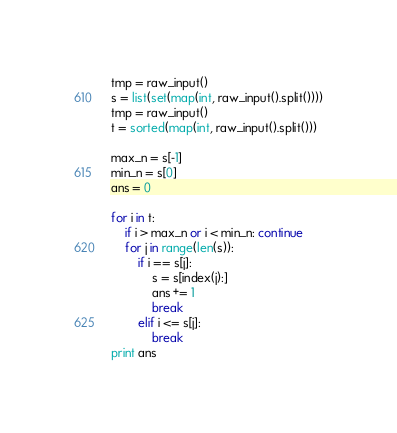Convert code to text. <code><loc_0><loc_0><loc_500><loc_500><_Python_>tmp = raw_input()
s = list(set(map(int, raw_input().split())))
tmp = raw_input()
t = sorted(map(int, raw_input().split()))

max_n = s[-1]
min_n = s[0]
ans = 0

for i in t:
	if i > max_n or i < min_n: continue
	for j in range(len(s)):
		if i == s[j]:
			s = s[index(j):]
			ans += 1
			break
		elif i <= s[j]:
			break
print ans</code> 